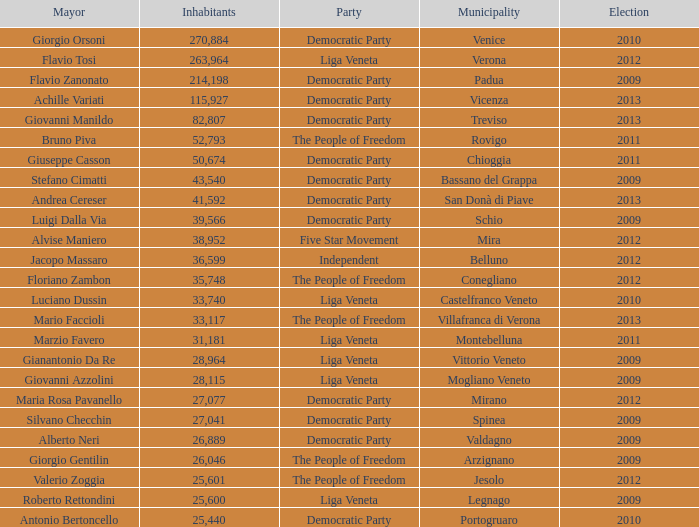How many Inhabitants were in the democratic party for an election before 2009 for Mayor of stefano cimatti? 0.0. 